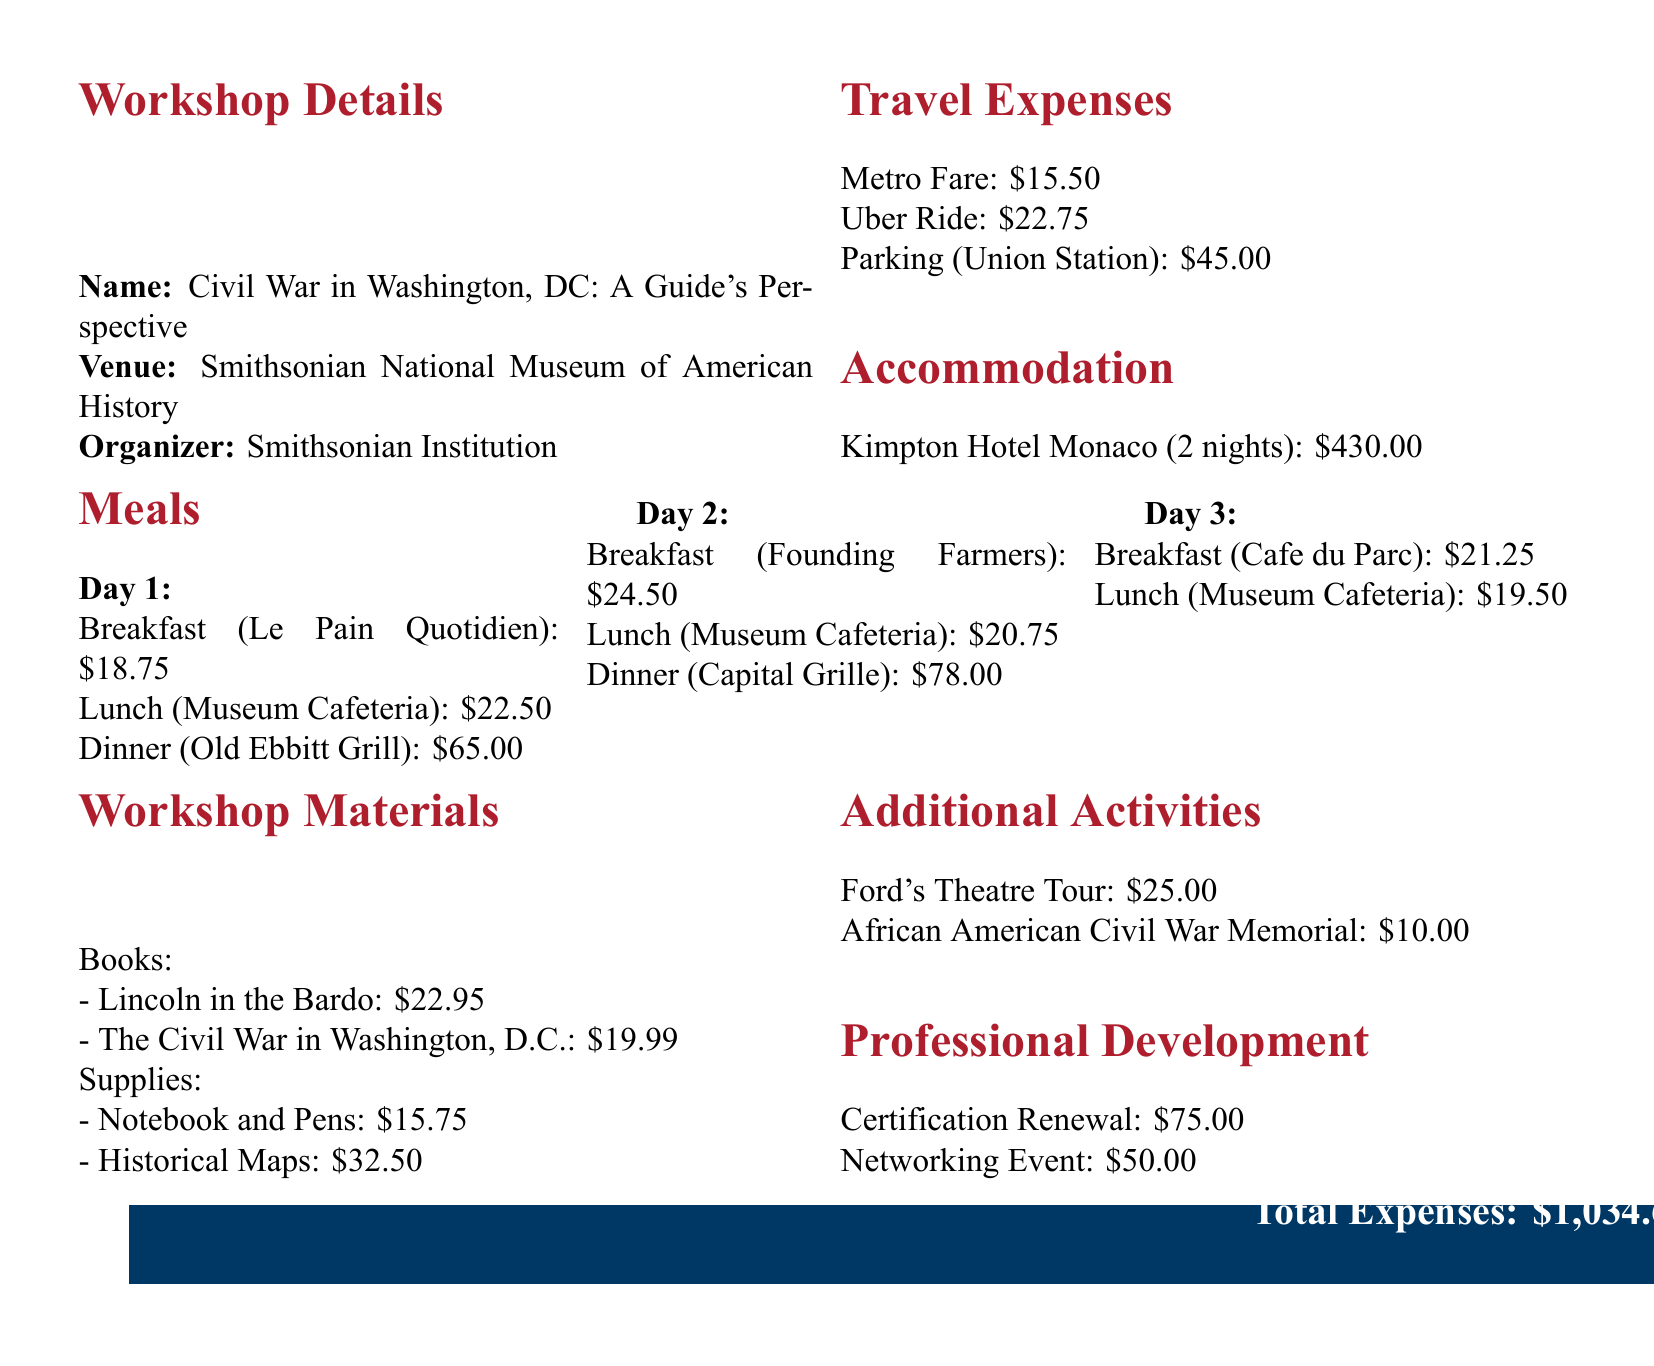what is the name of the workshop? The document states the workshop is titled "Civil War in Washington, DC: A Guide's Perspective."
Answer: Civil War in Washington, DC: A Guide's Perspective what is the date of the workshop? The workshop is scheduled to take place from May 15 to May 17, 2023.
Answer: May 15-17, 2023 how much was spent on parking? The expense document lists the parking cost at Union Station Garage as $45.00.
Answer: $45.00 what is the total cost for accommodation? The total accommodation expense at Kimpton Hotel Monaco for 2 nights is given as $430.00.
Answer: $430.00 how much was spent on dinner on Day 2? The document lists two dinners for Day 2: Capital Grille at $78.00 and the previous meal was at the Museum Cafeteria, which has a different cost for lunch.
Answer: $78.00 how many nights did the accommodation last? The document indicates that the stay at Kimpton Hotel Monaco was for 2 nights.
Answer: 2 what is the cost of the breakfast on Day 1? The document specifies the breakfast cost at Le Pain Quotidien on Day 1 as $18.75.
Answer: $18.75 what is the total amount of meal expenses? To find the total meal expenses, all individual meal costs from the three days should be summed. The combined total is $18.75 + $22.50 + $65.00 + $24.50 + $20.75 + $78.00 + $21.25 + $19.50.
Answer: $265.50 how much was spent on workshop materials? The document provides a breakdown of workshop materials: books cost $42.94 and supplies cost $48.25, leading to a total of $91.19.
Answer: $91.19 